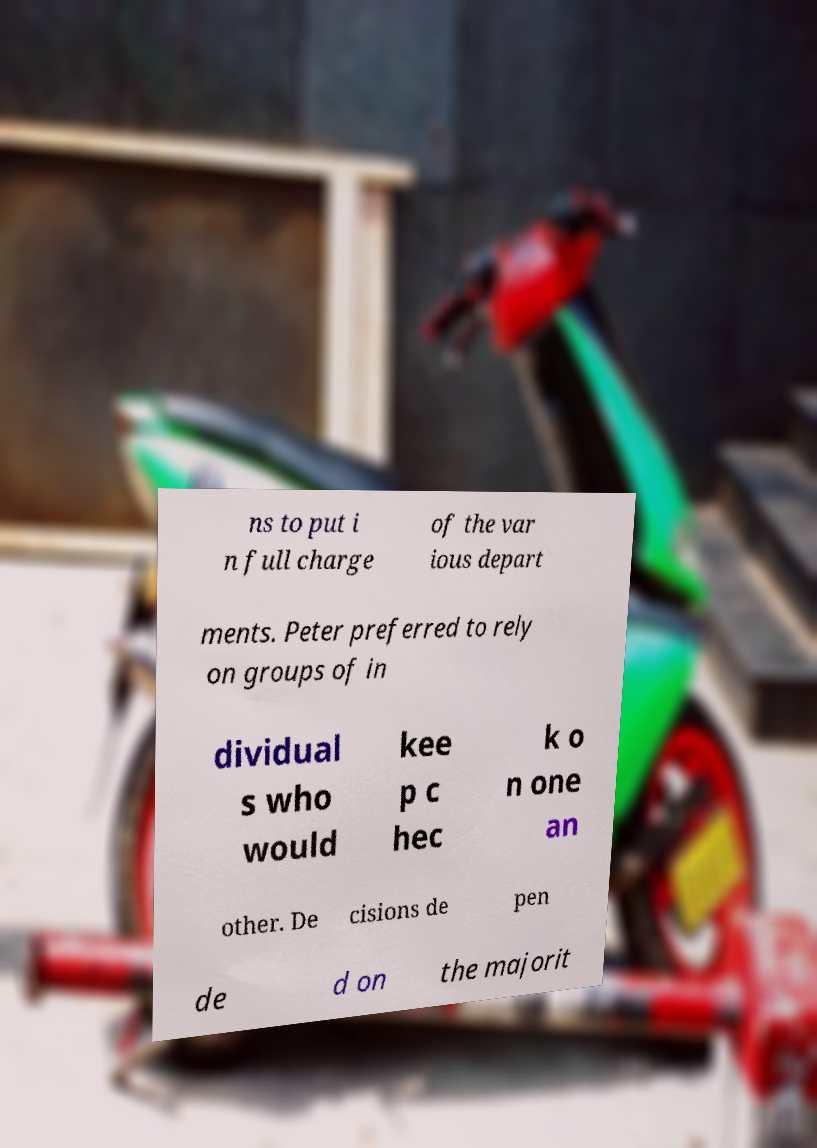Can you accurately transcribe the text from the provided image for me? ns to put i n full charge of the var ious depart ments. Peter preferred to rely on groups of in dividual s who would kee p c hec k o n one an other. De cisions de pen de d on the majorit 